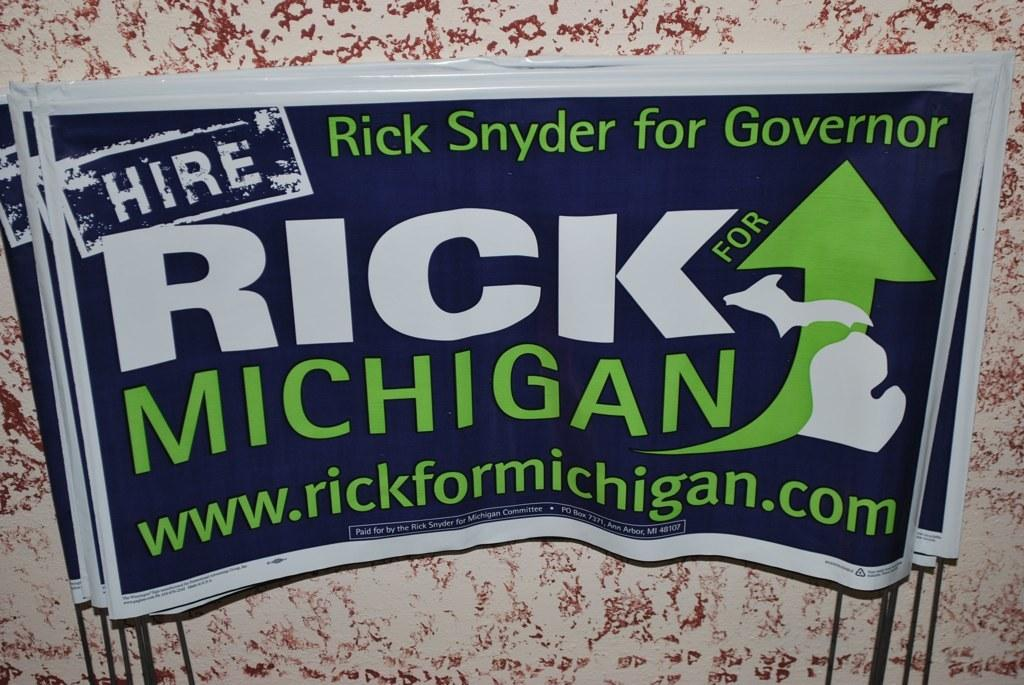<image>
Present a compact description of the photo's key features. a Hire Rick Michigan sign on an item 